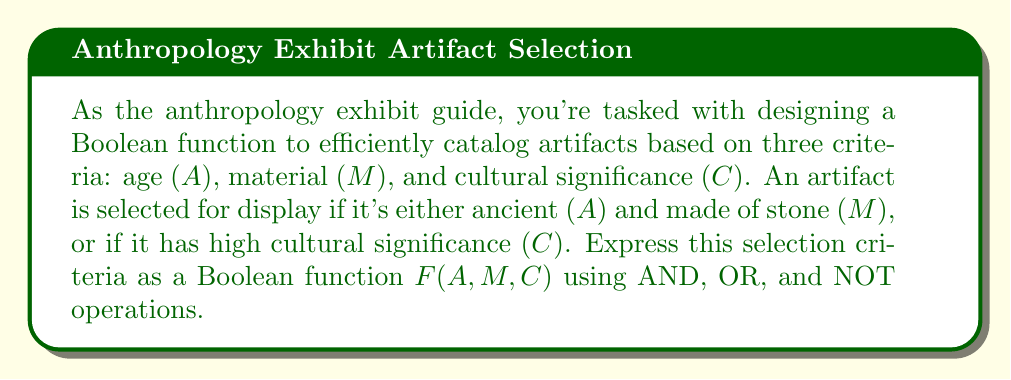Can you answer this question? Let's approach this step-by-step:

1) First, let's define our variables:
   A: The artifact is ancient (1 if true, 0 if false)
   M: The artifact is made of stone (1 if true, 0 if false)
   C: The artifact has high cultural significance (1 if true, 0 if false)

2) Now, let's break down the selection criteria:
   - Condition 1: The artifact is ancient AND made of stone
   - Condition 2: The artifact has high cultural significance

3) We can express Condition 1 mathematically as:
   $A \cdot M$

4) Condition 2 is simply:
   $C$

5) The artifact is selected if EITHER Condition 1 OR Condition 2 is true. In Boolean algebra, we represent OR with the + symbol.

6) Therefore, our Boolean function F(A,M,C) is:
   $F(A,M,C) = (A \cdot M) + C$

This function will output 1 (true) if the artifact should be selected for display, and 0 (false) otherwise.
Answer: $F(A,M,C) = (A \cdot M) + C$ 